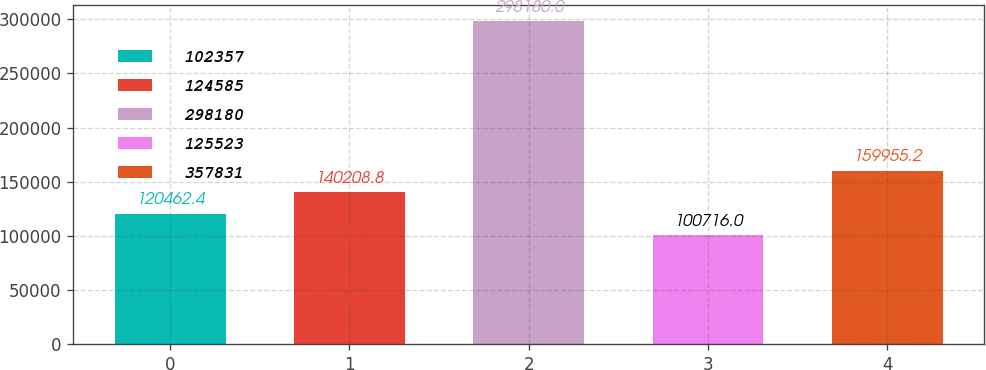<chart> <loc_0><loc_0><loc_500><loc_500><bar_chart><fcel>102357<fcel>124585<fcel>298180<fcel>125523<fcel>357831<nl><fcel>120462<fcel>140209<fcel>298180<fcel>100716<fcel>159955<nl></chart> 